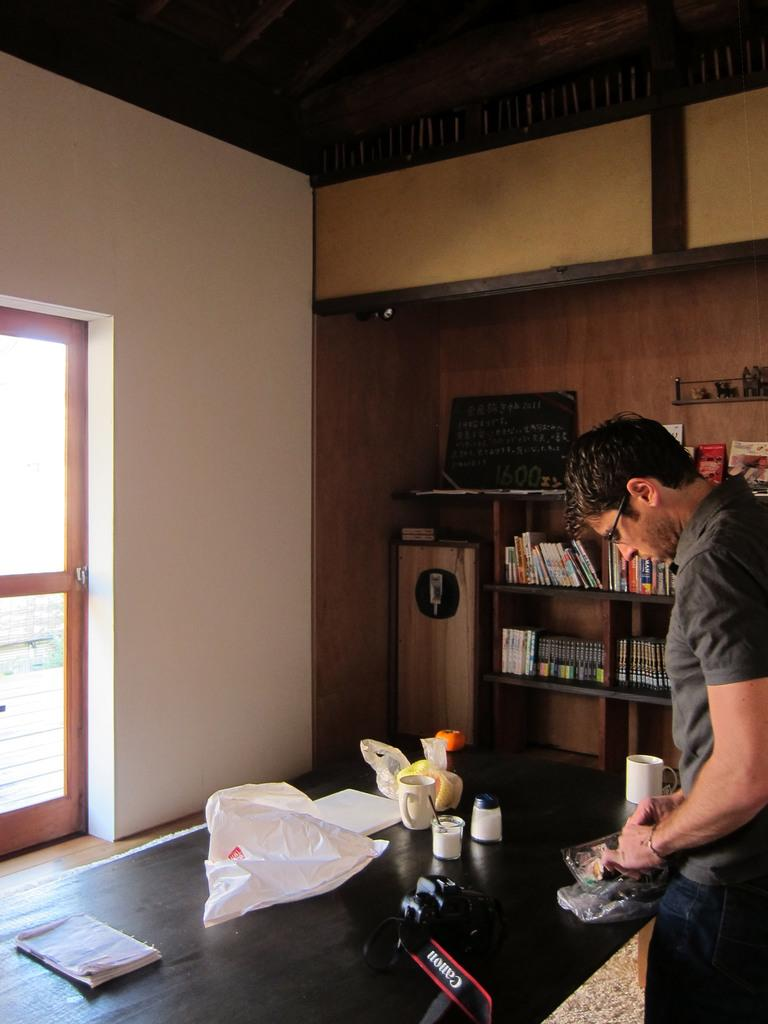<image>
Offer a succinct explanation of the picture presented. Man making some kind of design on a black table, and a camera from canon on the table. 